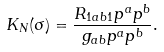Convert formula to latex. <formula><loc_0><loc_0><loc_500><loc_500>K _ { N } ( \sigma ) = \frac { R _ { 1 a b 1 } p ^ { a } p ^ { b } } { g _ { a b } p ^ { a } p ^ { b } } .</formula> 